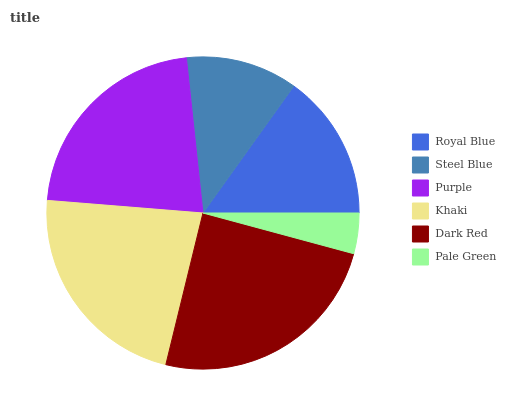Is Pale Green the minimum?
Answer yes or no. Yes. Is Dark Red the maximum?
Answer yes or no. Yes. Is Steel Blue the minimum?
Answer yes or no. No. Is Steel Blue the maximum?
Answer yes or no. No. Is Royal Blue greater than Steel Blue?
Answer yes or no. Yes. Is Steel Blue less than Royal Blue?
Answer yes or no. Yes. Is Steel Blue greater than Royal Blue?
Answer yes or no. No. Is Royal Blue less than Steel Blue?
Answer yes or no. No. Is Purple the high median?
Answer yes or no. Yes. Is Royal Blue the low median?
Answer yes or no. Yes. Is Steel Blue the high median?
Answer yes or no. No. Is Dark Red the low median?
Answer yes or no. No. 